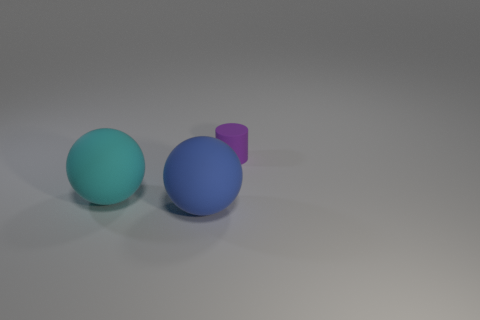Add 3 large blue matte objects. How many objects exist? 6 Subtract all balls. How many objects are left? 1 Subtract 0 red cylinders. How many objects are left? 3 Subtract all large cyan balls. Subtract all small gray metal blocks. How many objects are left? 2 Add 2 big blue rubber balls. How many big blue rubber balls are left? 3 Add 1 purple metallic cylinders. How many purple metallic cylinders exist? 1 